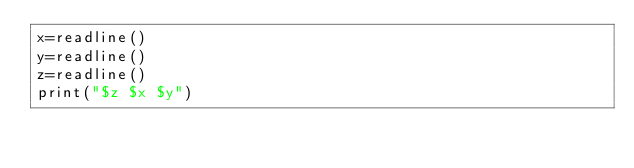Convert code to text. <code><loc_0><loc_0><loc_500><loc_500><_Julia_>x=readline()
y=readline()
z=readline()
print("$z $x $y")
</code> 